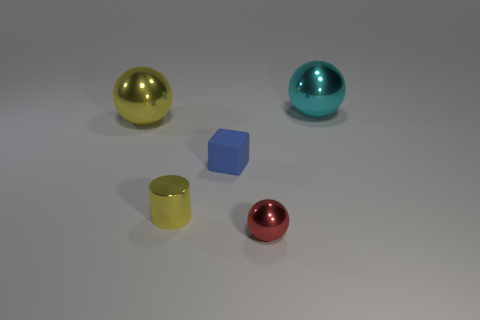Are there more big blue objects than tiny things?
Your answer should be very brief. No. How many other things are made of the same material as the tiny block?
Offer a very short reply. 0. What number of things are either small spheres or yellow balls on the left side of the yellow cylinder?
Your answer should be very brief. 2. Are there fewer small green rubber blocks than small things?
Offer a terse response. Yes. There is a large metal ball that is in front of the big shiny ball that is behind the yellow thing that is behind the tiny cube; what color is it?
Give a very brief answer. Yellow. Does the cyan ball have the same material as the small blue object?
Your response must be concise. No. How many cyan objects are to the right of the red ball?
Your response must be concise. 1. The red object that is the same shape as the big cyan object is what size?
Your answer should be very brief. Small. What number of cyan things are either metallic cylinders or large metallic objects?
Offer a very short reply. 1. There is a small thing that is to the right of the blue cube; what number of tiny things are in front of it?
Offer a very short reply. 0. 